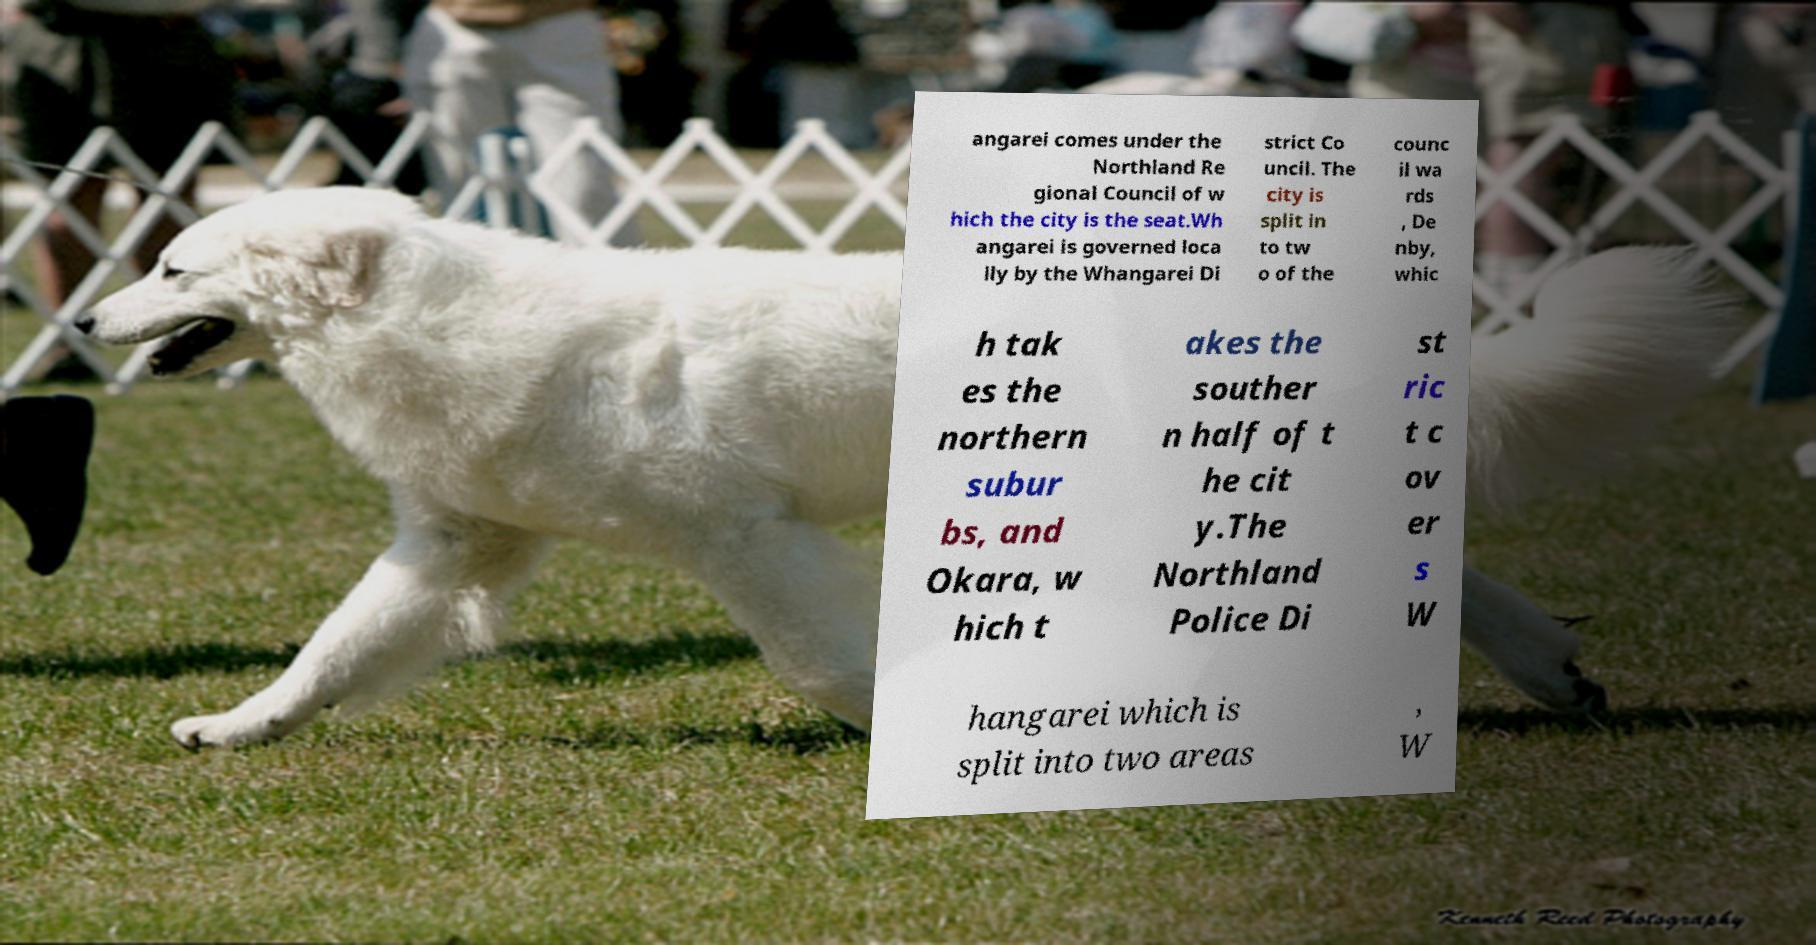Please read and relay the text visible in this image. What does it say? angarei comes under the Northland Re gional Council of w hich the city is the seat.Wh angarei is governed loca lly by the Whangarei Di strict Co uncil. The city is split in to tw o of the counc il wa rds , De nby, whic h tak es the northern subur bs, and Okara, w hich t akes the souther n half of t he cit y.The Northland Police Di st ric t c ov er s W hangarei which is split into two areas , W 